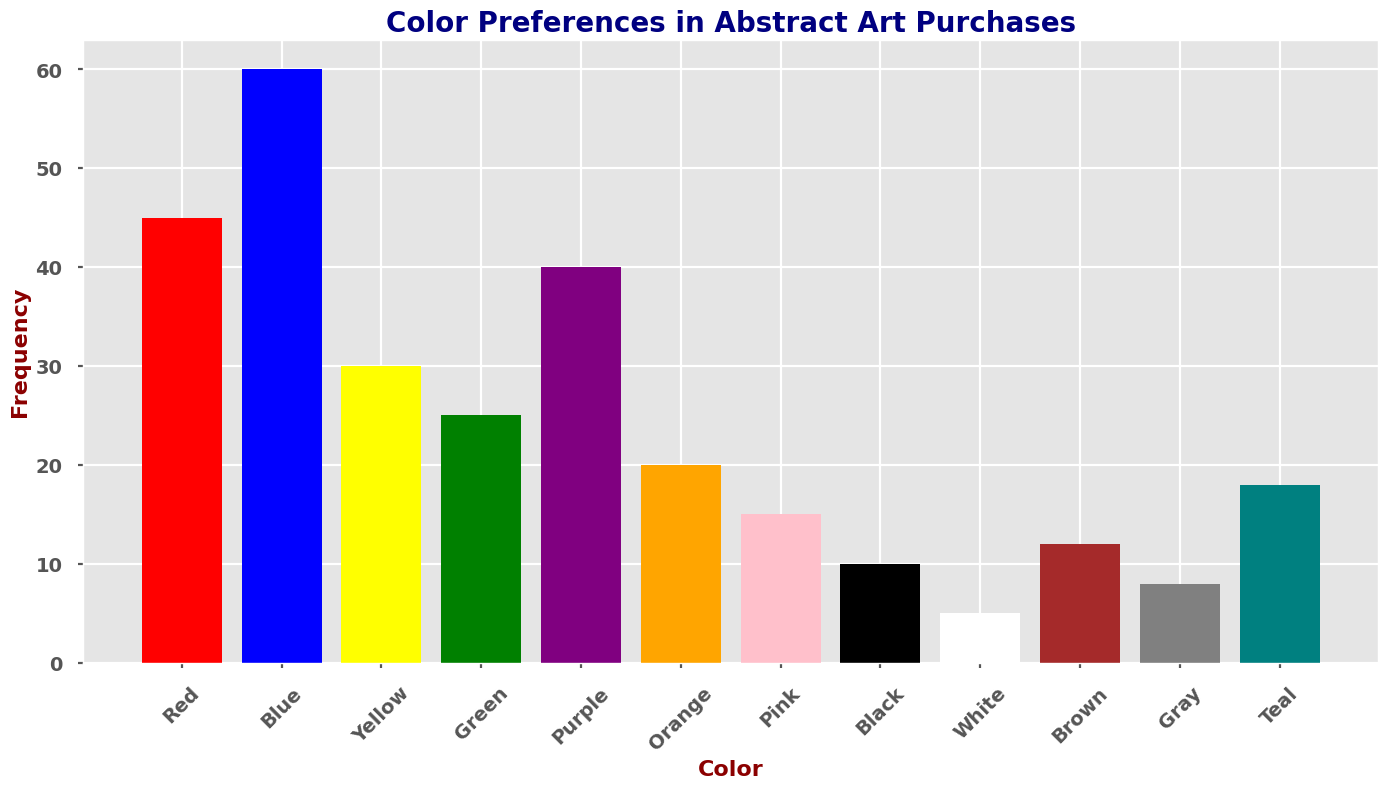What's the most preferred color for abstract art purchases? From the histogram, the color with the highest frequency is the tallest bar. The blue bar is the tallest, indicating it is the most preferred color.
Answer: Blue Which colors have a frequency higher than 40? By examining the heights of the bars in the histogram, we see that Red, Blue, and Purple have heights that represent frequencies higher than 40.
Answer: Red, Blue, Purple What is the combined frequency of Yellow, Green, and Teal? The frequencies given in the data are Yellow (30), Green (25), and Teal (18). Adding these together: 30 + 25 + 18 = 73.
Answer: 73 How does the frequency of Black compare to White? From the histogram, the height of the Black bar is 10 and the height of the White bar is 5. The Black bar is taller, indicating that Black is more frequent than White.
Answer: Black is more frequent than White Which color has the lowest frequency? The shortest bar represents the lowest frequency. The White bar is the shortest, with a frequency of 5.
Answer: White Is the frequency of Orange greater than the combined frequency of Pink and White? Orange has a frequency of 20, while Pink and White have frequencies of 15 and 5 respectively. Combined frequency of Pink and White = 15 + 5 = 20. Since 20 is equal to 20, Orange is not greater.
Answer: No What colors have frequencies less than 20? By checking the histogram, the colors with bars shorter than 20 on the y-axis are Pink (15), Black (10), White (5), Brown (12), and Gray (8).
Answer: Pink, Black, White, Brown, Gray What's the total frequency of all the colors shown in the histogram? Adding all the given frequencies: 45 (Red) + 60 (Blue) + 30 (Yellow) + 25 (Green) + 40 (Purple) + 20 (Orange) + 15 (Pink) + 10 (Black) + 5 (White) + 12 (Brown) + 8 (Gray) + 18 (Teal) = 288.
Answer: 288 Which two colors have the closest frequency values? By examining the histogram, Orange (20) and Teal (18) have frequency values that differ by 2, the smallest difference.
Answer: Orange and Teal How much greater is the frequency of Blue than the average frequency of all colors? The total frequency is 288 and there are 12 colors. So, the average frequency is 288 / 12 = 24. Frequency of Blue is 60. Difference = 60 - 24 = 36.
Answer: 36 